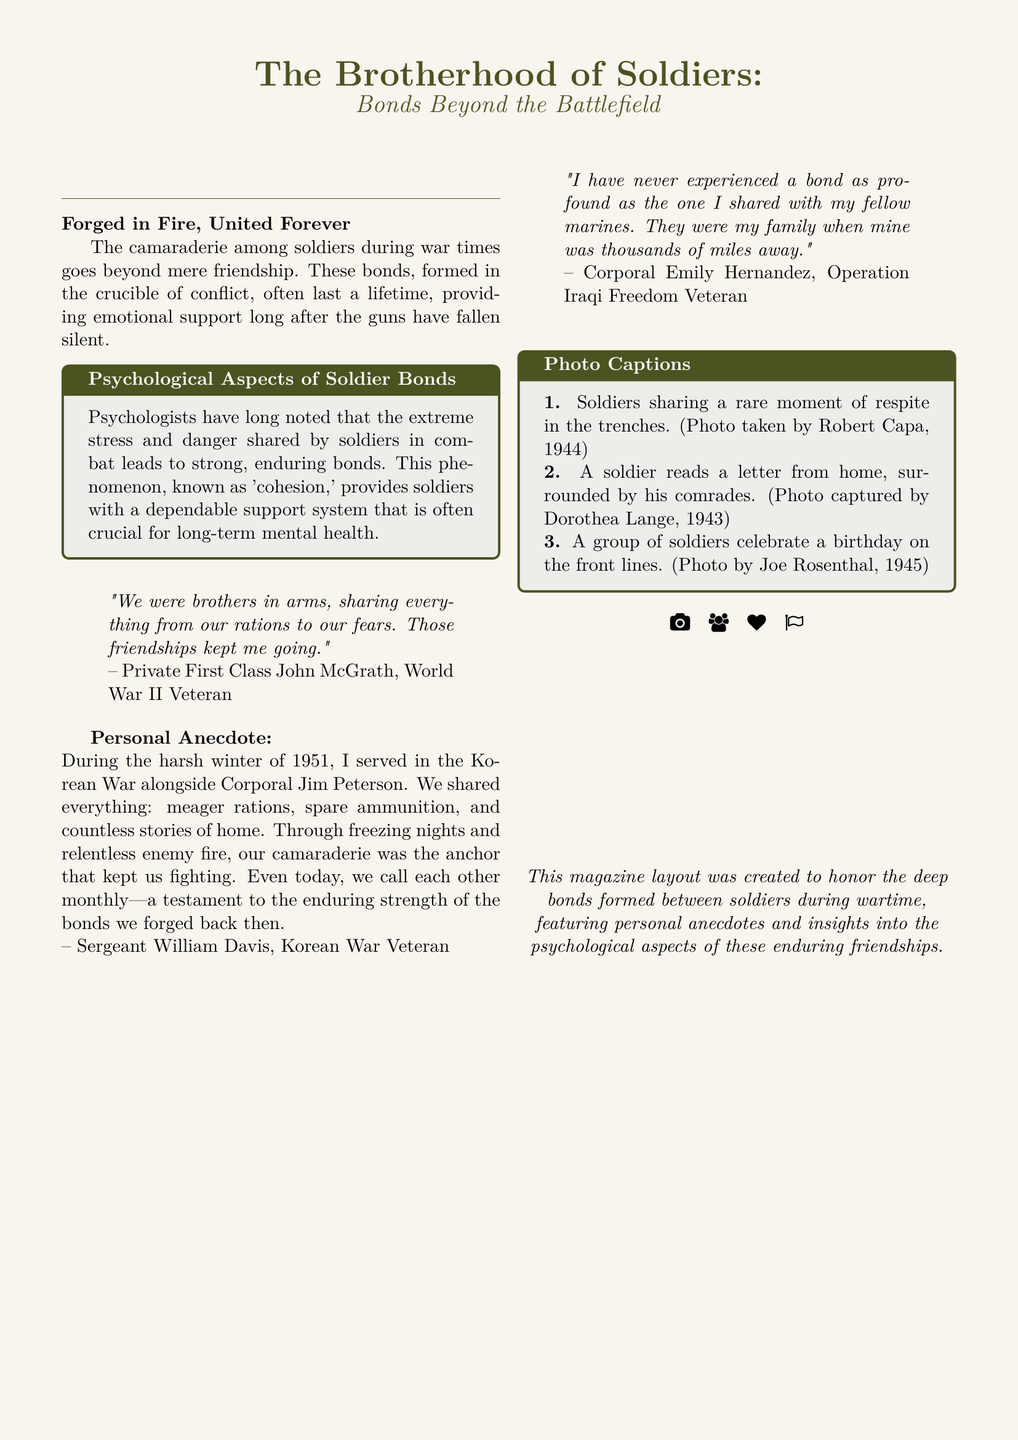What is the title of the article? The title is found at the beginning of the document, indicating the main focus of the piece.
Answer: The Brotherhood of Soldiers: Bonds Beyond the Battlefield Who is the World War II veteran quoted? This information can be found in the quote section of the document, providing specific identities of the veterans featured.
Answer: Private First Class John McGrath What significant event is mentioned in the personal anecdote? The personal anecdote recounts a specific time and place from a veteran's experience during the war.
Answer: Korean War How often do Sergeant William Davis and Corporal Jim Peterson communicate? This detail reveals the ongoing relationship between the veterans after the war, as stated in the personal anecdote.
Answer: Monthly What are the colors used in the document? The document prominently features specific colors that are mentioned in the formatting instructions.
Answer: Army green and sand brown What does the tcolorbox titled "Psychological Aspects of Soldier Bonds" discuss? This element of the document provides insights into the psychological impact of the bonds formed during warfare.
Answer: Cohesion Who is the Mexican-American veteran mentioned in the quotes? This name highlights diverse experiences in the military and provides insight into the bonds formed irrespective of background.
Answer: Corporal Emily Hernandez What year is the photo of soldiers celebrating a birthday taken? This detail can be found in the captions under the photo section, providing specific historical context.
Answer: 1945 